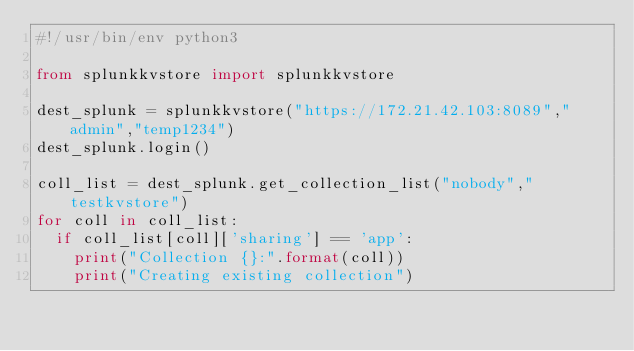Convert code to text. <code><loc_0><loc_0><loc_500><loc_500><_Python_>#!/usr/bin/env python3

from splunkkvstore import splunkkvstore

dest_splunk = splunkkvstore("https://172.21.42.103:8089","admin","temp1234")
dest_splunk.login()

coll_list = dest_splunk.get_collection_list("nobody","testkvstore")
for coll in coll_list:
	if coll_list[coll]['sharing'] == 'app':
		print("Collection {}:".format(coll))
		print("Creating existing collection")</code> 